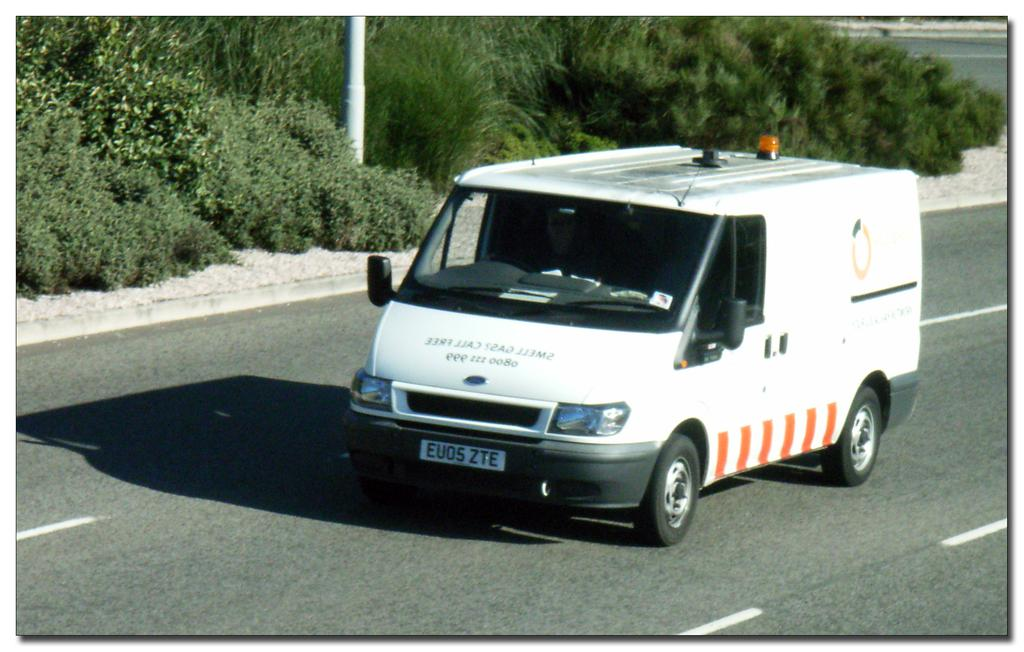<image>
Share a concise interpretation of the image provided. A white van drives down the road with a license plate displaying the characters EVOS ZTE. 